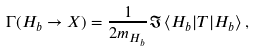<formula> <loc_0><loc_0><loc_500><loc_500>\Gamma ( H _ { b } \rightarrow X ) = \frac { 1 } { 2 m _ { H _ { b } } } \Im \, \langle H _ { b } | { T } | H _ { b } \rangle \, ,</formula> 